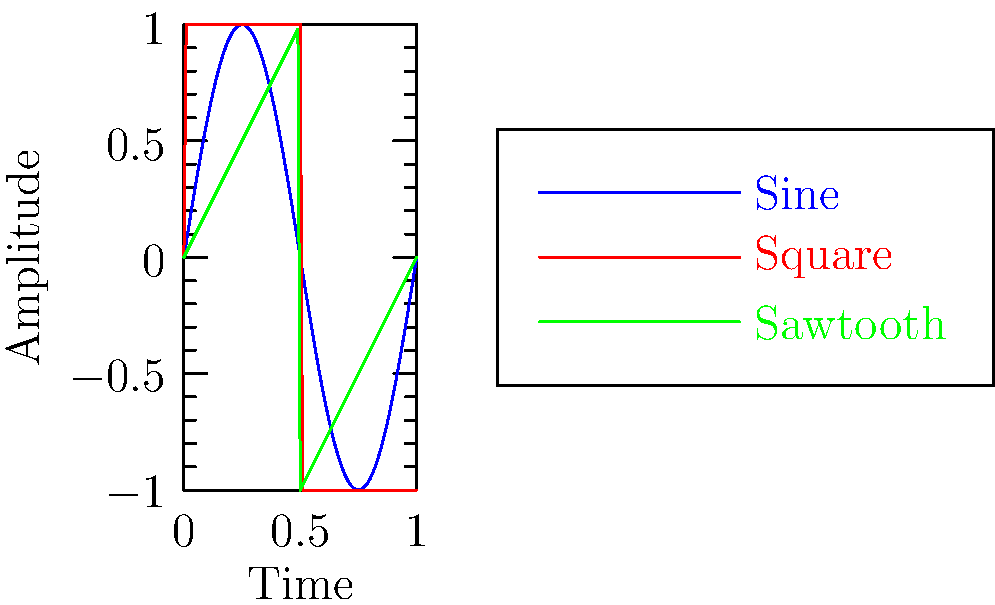In the context of Nepalese traditional music, which of the waveforms shown in the oscilloscope display (sine, square, or sawtooth) would most closely resemble the sound produced by a damaru, a small two-headed drum used in religious ceremonies? To answer this question, we need to consider the characteristics of each waveform and relate them to the sound of a damaru:

1. Sine wave (blue): Produces a pure tone with no harmonics, typically associated with simple electronic tones or tuning forks.

2. Square wave (red): Characterized by abrupt transitions between two fixed voltage levels, rich in odd harmonics. Often associated with harsh, buzzy sounds.

3. Sawtooth wave (green): Features a linear rise followed by a sharp drop, contains both even and odd harmonics. Produces a bright, edgy sound.

4. Damaru characteristics:
   - Produces a short, percussive sound
   - Has a quick attack and decay
   - Sound is rich in harmonics due to the drum's construction and playing technique

5. Comparison:
   - Sine wave is too smooth and lacks the harmonic richness of a drum
   - Square wave has abrupt transitions similar to percussion, but lacks the gradual decay
   - Sawtooth wave has a sharp attack (the vertical drop) followed by a more gradual change (the diagonal rise), which better approximates the quick attack and decay of a drum hit

6. Cultural context:
   - The damaru is often used in Hindu and Buddhist rituals, producing a distinct "da-ding" sound
   - This sound is more closely represented by the sharp attack and gradual decay of a sawtooth wave

Therefore, while no simple waveform perfectly captures the complexity of a damaru's sound, the sawtooth wave most closely approximates its percussive nature and harmonic content.
Answer: Sawtooth wave 